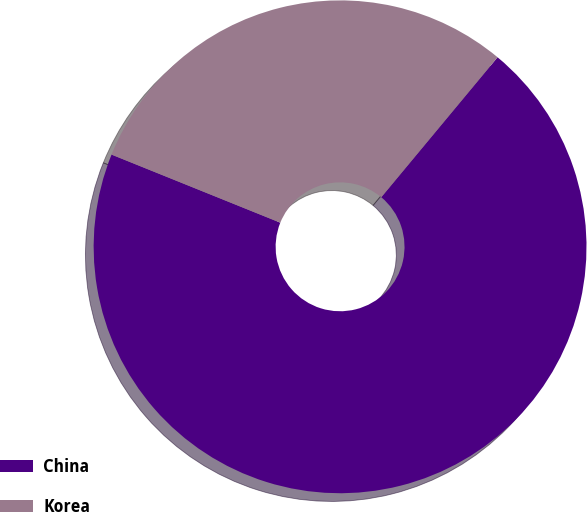Convert chart. <chart><loc_0><loc_0><loc_500><loc_500><pie_chart><fcel>China<fcel>Korea<nl><fcel>70.07%<fcel>29.93%<nl></chart> 